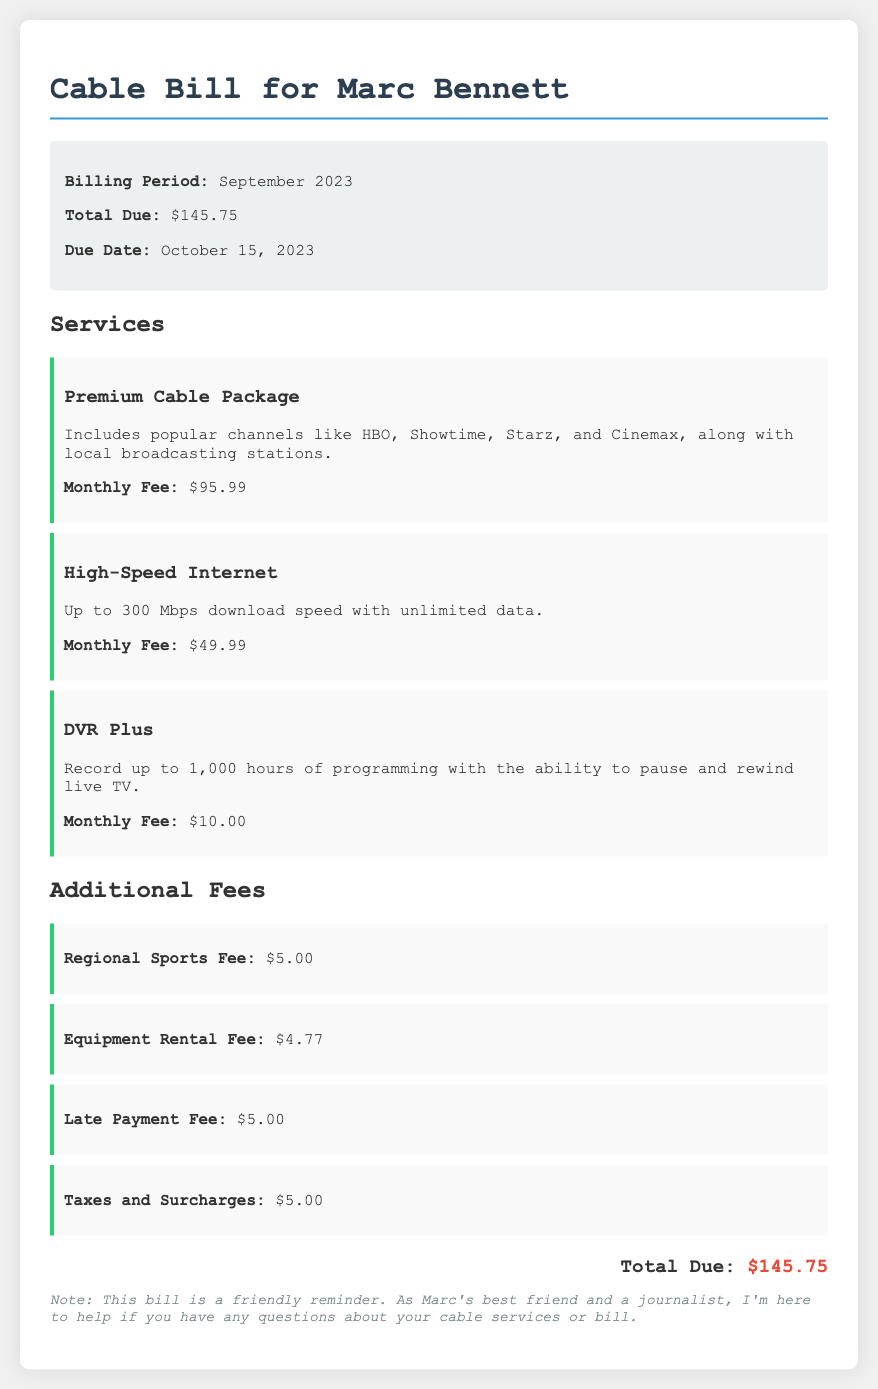What is the billing period? The billing period is the specific time frame for the services provided, which is September 2023.
Answer: September 2023 What is the total due amount? The total due is the amount that needs to be paid, listed in the document as $145.75.
Answer: $145.75 When is the due date? The due date indicates when the payment must be made, which is October 15, 2023.
Answer: October 15, 2023 How much is the monthly fee for the Premium Cable Package? This fee is specified in the document as $95.99 for the service listed.
Answer: $95.99 What is included in the High-Speed Internet package? The document describes the package's features, noting its download speed and data limitations.
Answer: Up to 300 Mbps download speed with unlimited data What are the additional fees listed? This question requires referring to multiple fees in the document for a complete answer.
Answer: Regional Sports Fee, Equipment Rental Fee, Late Payment Fee, Taxes and Surcharges What is the fee for the DVR Plus? The document states the monthly fee for this service distinctly.
Answer: $10.00 What is the total amount of the additional fees? This requires calculation of all additional fees mentioned, which total $19.77.
Answer: $19.77 Is there a late payment fee? A late payment fee is specifically noted in the document, indicating its existence and amount.
Answer: Yes, $5.00 